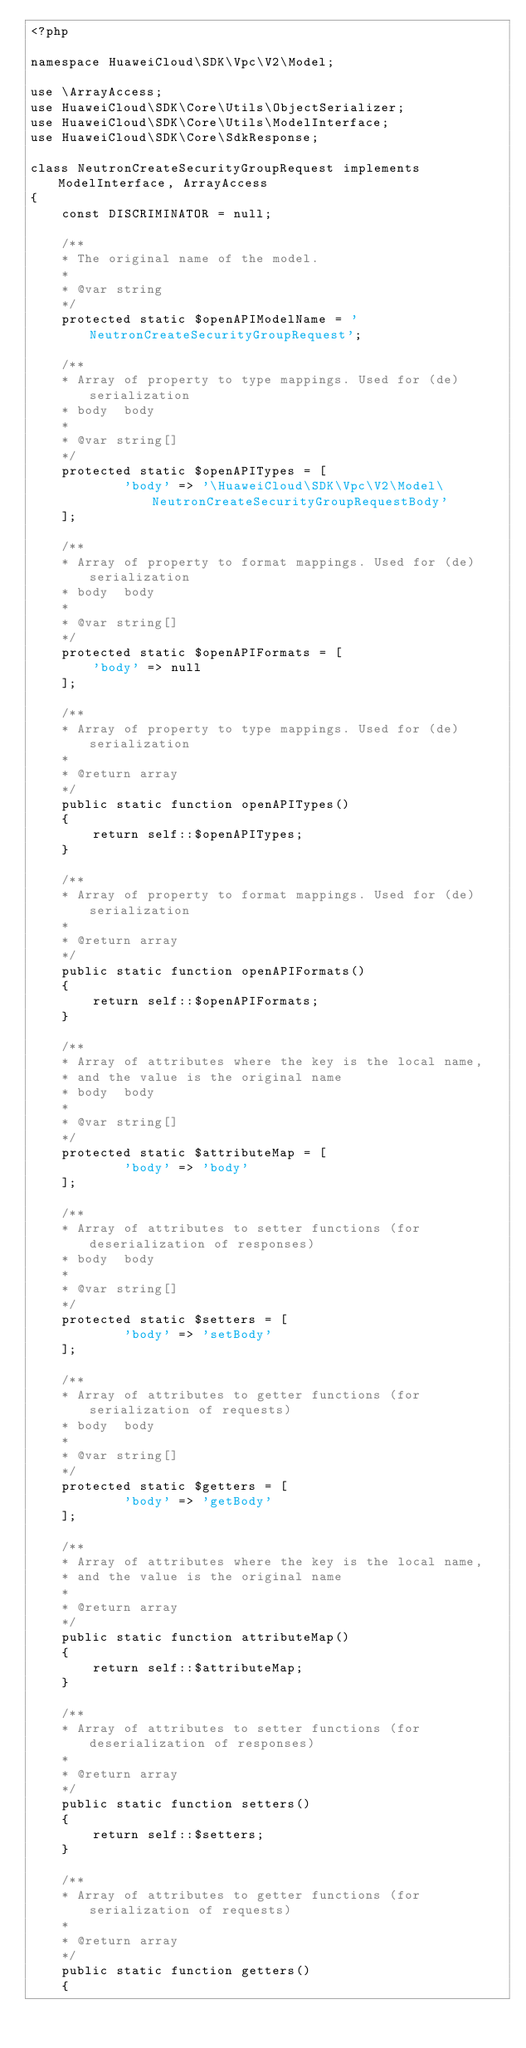<code> <loc_0><loc_0><loc_500><loc_500><_PHP_><?php

namespace HuaweiCloud\SDK\Vpc\V2\Model;

use \ArrayAccess;
use HuaweiCloud\SDK\Core\Utils\ObjectSerializer;
use HuaweiCloud\SDK\Core\Utils\ModelInterface;
use HuaweiCloud\SDK\Core\SdkResponse;

class NeutronCreateSecurityGroupRequest implements ModelInterface, ArrayAccess
{
    const DISCRIMINATOR = null;

    /**
    * The original name of the model.
    *
    * @var string
    */
    protected static $openAPIModelName = 'NeutronCreateSecurityGroupRequest';

    /**
    * Array of property to type mappings. Used for (de)serialization
    * body  body
    *
    * @var string[]
    */
    protected static $openAPITypes = [
            'body' => '\HuaweiCloud\SDK\Vpc\V2\Model\NeutronCreateSecurityGroupRequestBody'
    ];

    /**
    * Array of property to format mappings. Used for (de)serialization
    * body  body
    *
    * @var string[]
    */
    protected static $openAPIFormats = [
        'body' => null
    ];

    /**
    * Array of property to type mappings. Used for (de)serialization
    *
    * @return array
    */
    public static function openAPITypes()
    {
        return self::$openAPITypes;
    }

    /**
    * Array of property to format mappings. Used for (de)serialization
    *
    * @return array
    */
    public static function openAPIFormats()
    {
        return self::$openAPIFormats;
    }

    /**
    * Array of attributes where the key is the local name,
    * and the value is the original name
    * body  body
    *
    * @var string[]
    */
    protected static $attributeMap = [
            'body' => 'body'
    ];

    /**
    * Array of attributes to setter functions (for deserialization of responses)
    * body  body
    *
    * @var string[]
    */
    protected static $setters = [
            'body' => 'setBody'
    ];

    /**
    * Array of attributes to getter functions (for serialization of requests)
    * body  body
    *
    * @var string[]
    */
    protected static $getters = [
            'body' => 'getBody'
    ];

    /**
    * Array of attributes where the key is the local name,
    * and the value is the original name
    *
    * @return array
    */
    public static function attributeMap()
    {
        return self::$attributeMap;
    }

    /**
    * Array of attributes to setter functions (for deserialization of responses)
    *
    * @return array
    */
    public static function setters()
    {
        return self::$setters;
    }

    /**
    * Array of attributes to getter functions (for serialization of requests)
    *
    * @return array
    */
    public static function getters()
    {</code> 